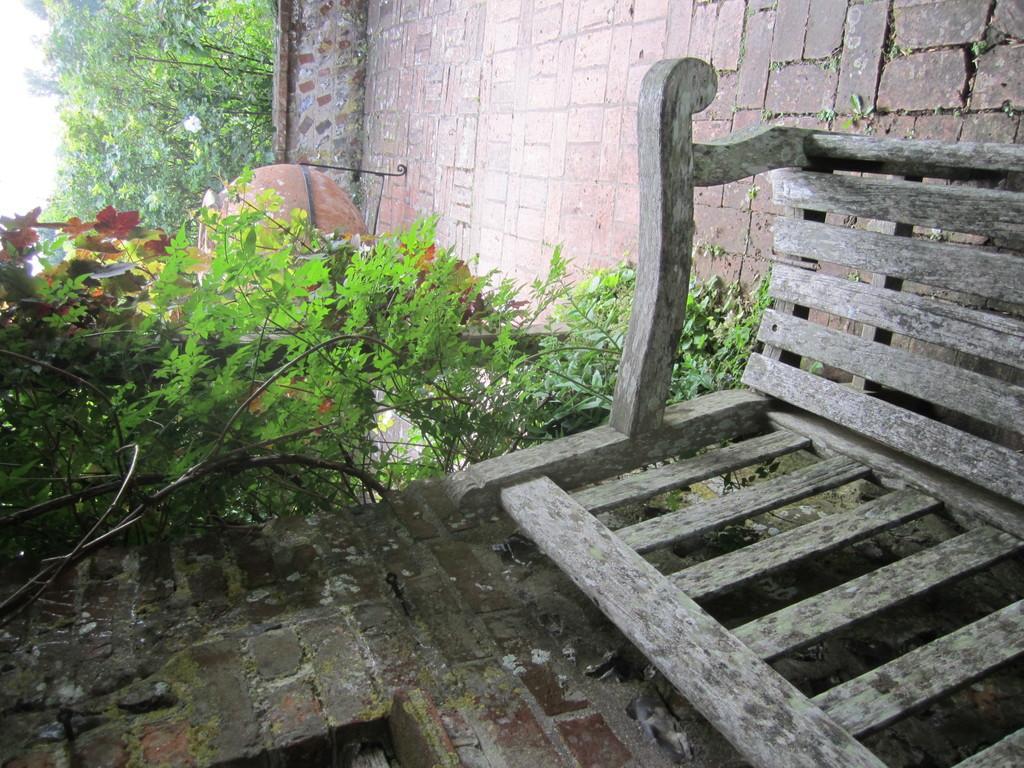In one or two sentences, can you explain what this image depicts? At the bottom of the image there is a bench. Behind the bench there is a brick wall and also there is a creeper with leaves. On the floor there is a stand with pot. Behind the pot there is a small wall. Behind the wall there are trees. 